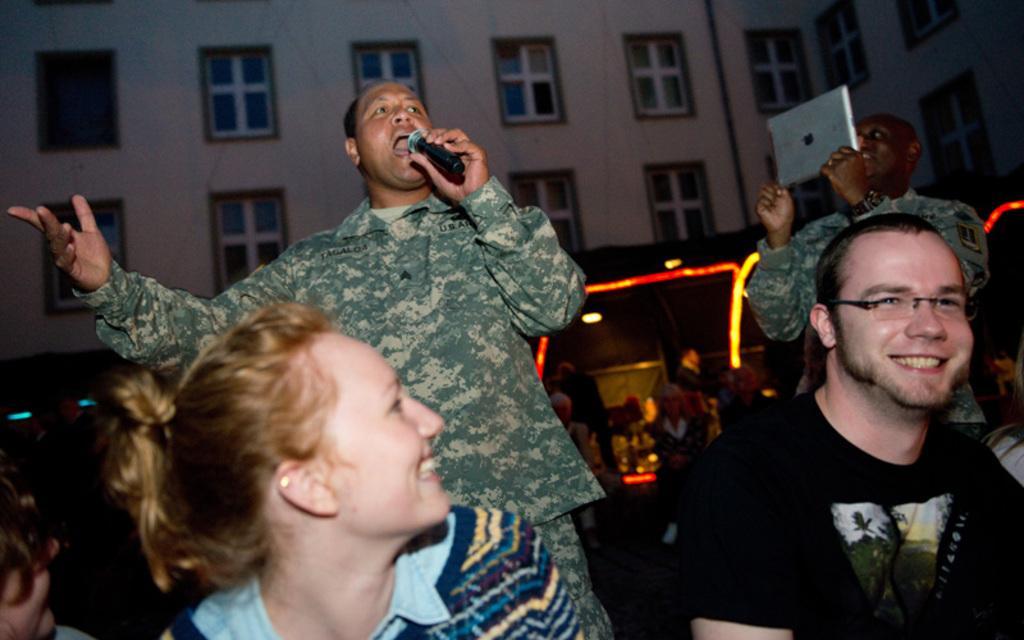In one or two sentences, can you explain what this image depicts? In this picture we can describe about a man wearing a military green soldier dress standing and singing on the microphone. In the front we can see a girl wearing blue color t-shirt is smiling. Beside we can see a man wearing a black color t-shirt sitting and smiling. Behind we can see another military soldier who is taking a video of a man who is singing. In the background we can see a building with many windows. 